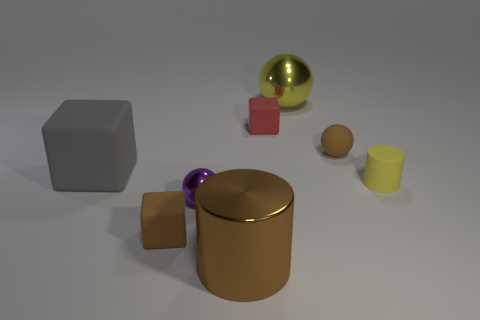Can you tell me about the materials and textures of the objects in this image? Certainly! The objects in the image exhibit varying materials and textures. The gray cube and the red block seem to have a matte finish, suggesting a non-reflective, possibly rough surface. The brown cylinder and the small yellow cylinder have a smooth, shiny metallic look. There's also a golden reflective sphere with a polished surface that appears almost mirror-like, and finally, a rubbery purple sphere, which has a subtle sheen that hints at its elastic material properties. 